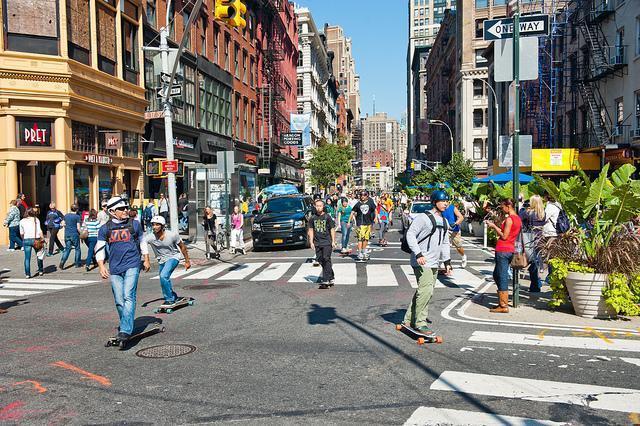How many people can be seen?
Give a very brief answer. 3. How many reflections of a cat are visible?
Give a very brief answer. 0. 